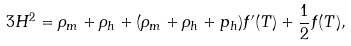Convert formula to latex. <formula><loc_0><loc_0><loc_500><loc_500>3 H ^ { 2 } = \rho _ { m } + \rho _ { h } + ( \rho _ { m } + \rho _ { h } + p _ { h } ) f ^ { \prime } ( T ) + \frac { 1 } { 2 } f ( T ) ,</formula> 